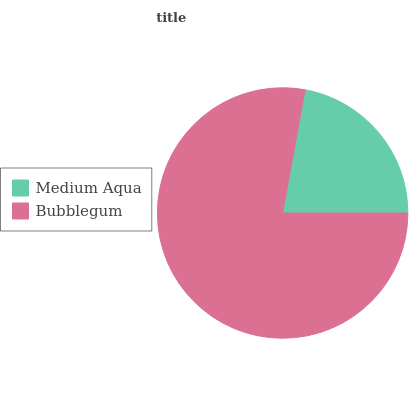Is Medium Aqua the minimum?
Answer yes or no. Yes. Is Bubblegum the maximum?
Answer yes or no. Yes. Is Bubblegum the minimum?
Answer yes or no. No. Is Bubblegum greater than Medium Aqua?
Answer yes or no. Yes. Is Medium Aqua less than Bubblegum?
Answer yes or no. Yes. Is Medium Aqua greater than Bubblegum?
Answer yes or no. No. Is Bubblegum less than Medium Aqua?
Answer yes or no. No. Is Bubblegum the high median?
Answer yes or no. Yes. Is Medium Aqua the low median?
Answer yes or no. Yes. Is Medium Aqua the high median?
Answer yes or no. No. Is Bubblegum the low median?
Answer yes or no. No. 